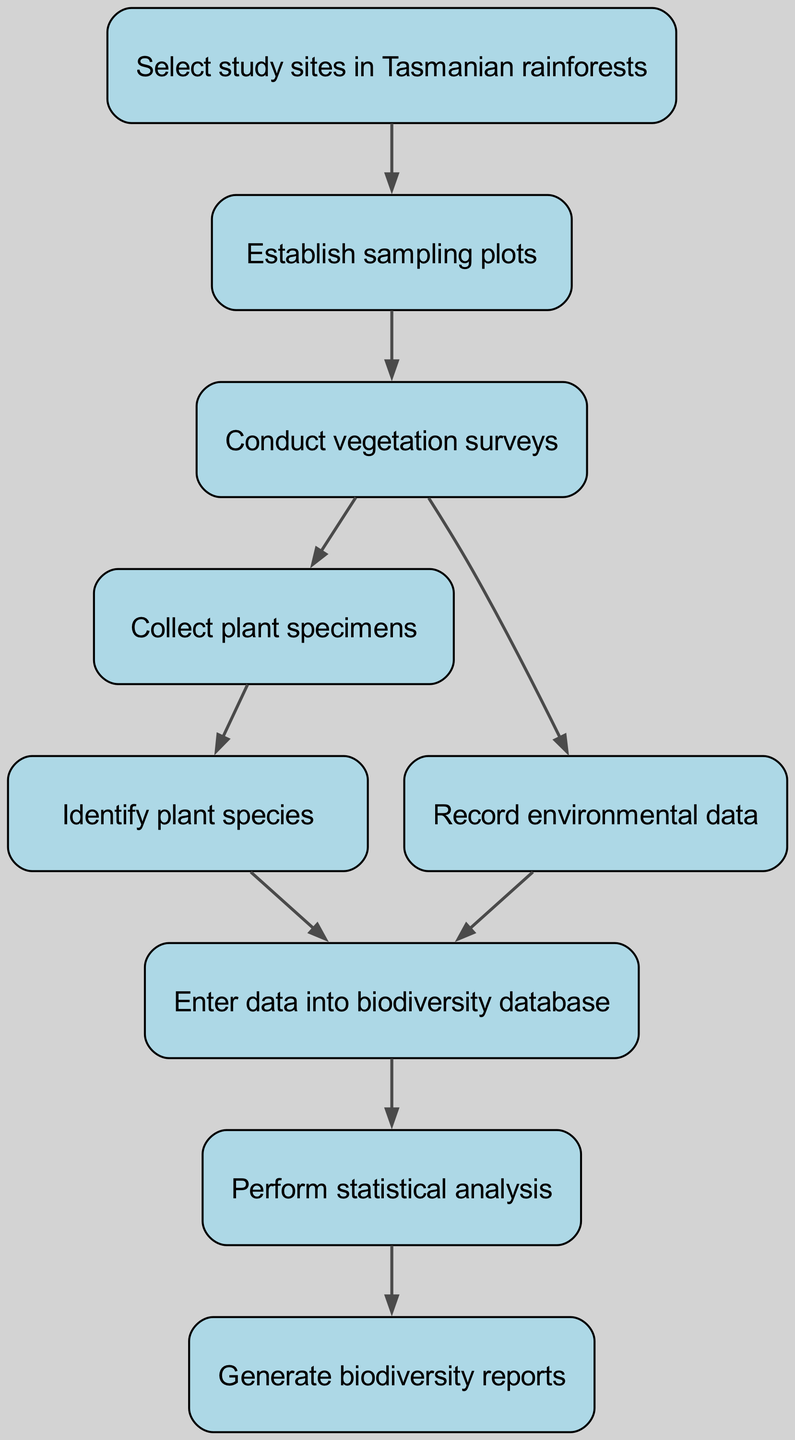What is the first step in the procedure? The first step in the diagram is labeled as "Select study sites in Tasmanian rainforests." It is the first node listed in the flowchart, indicating it’s the starting point of the data collection and analysis procedure.
Answer: Select study sites in Tasmanian rainforests How many nodes are in the diagram? To find the number of nodes, we can count the entries in the nodes list provided in the data. There are 9 distinct steps outlined in the flowchart.
Answer: 9 What step comes after identifying plant species? After identifying plant species, the next step is to "Enter data into biodiversity database." This is indicated by the edge that connects node 6 (Identifying plant species) to node 7 (Entering data into biodiversity database).
Answer: Enter data into biodiversity database What environmental data is recorded after conducting vegetation surveys? The diagram indicates that after conducting vegetation surveys (node 3), the procedure also involves recording environmental data (node 5). The connection is illustrated by an edge leading to node 5.
Answer: Record environmental data How does specimen collection relate to species identification? The flowchart shows that after collecting plant specimens (node 4), the next step is to identify plant species (node 6). There is a clear directional edge connecting these two nodes, indicating that specimen collection directly leads to the identification of species.
Answer: Identify plant species after collecting plant specimens What is the final output of the flowchart? The final output of the process is represented by the last node labeled as "Generate biodiversity reports." This indicates that after performing statistical analysis (node 8), the next action is to generate reports based on the collected data.
Answer: Generate biodiversity reports Which two steps are conducted simultaneously after conducting vegetation surveys? After conducting vegetation surveys (node 3), the flowchart indicates that two simultaneous actions occur: "Collect plant specimens" (node 4) and "Record environmental data" (node 5). Both nodes are directly connected to node 3, signifying they happen at the same time.
Answer: Collect plant specimens and Record environmental data What type of analysis is performed after entering data into the database? The diagram specifies that after entering data into the biodiversity database (node 7), the next action is to perform statistical analysis (node 8). This shows a direct relationship where entered data is the foundation for subsequent analysis.
Answer: Perform statistical analysis 